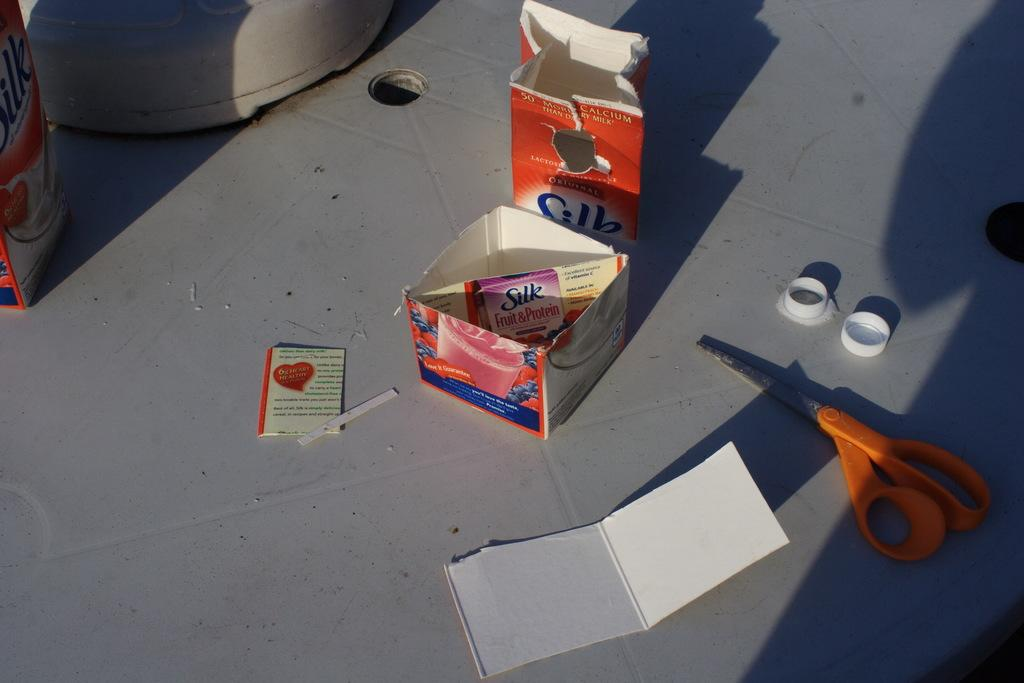<image>
Write a terse but informative summary of the picture. A Silk fruit and protein carton is cut up into pieces. 